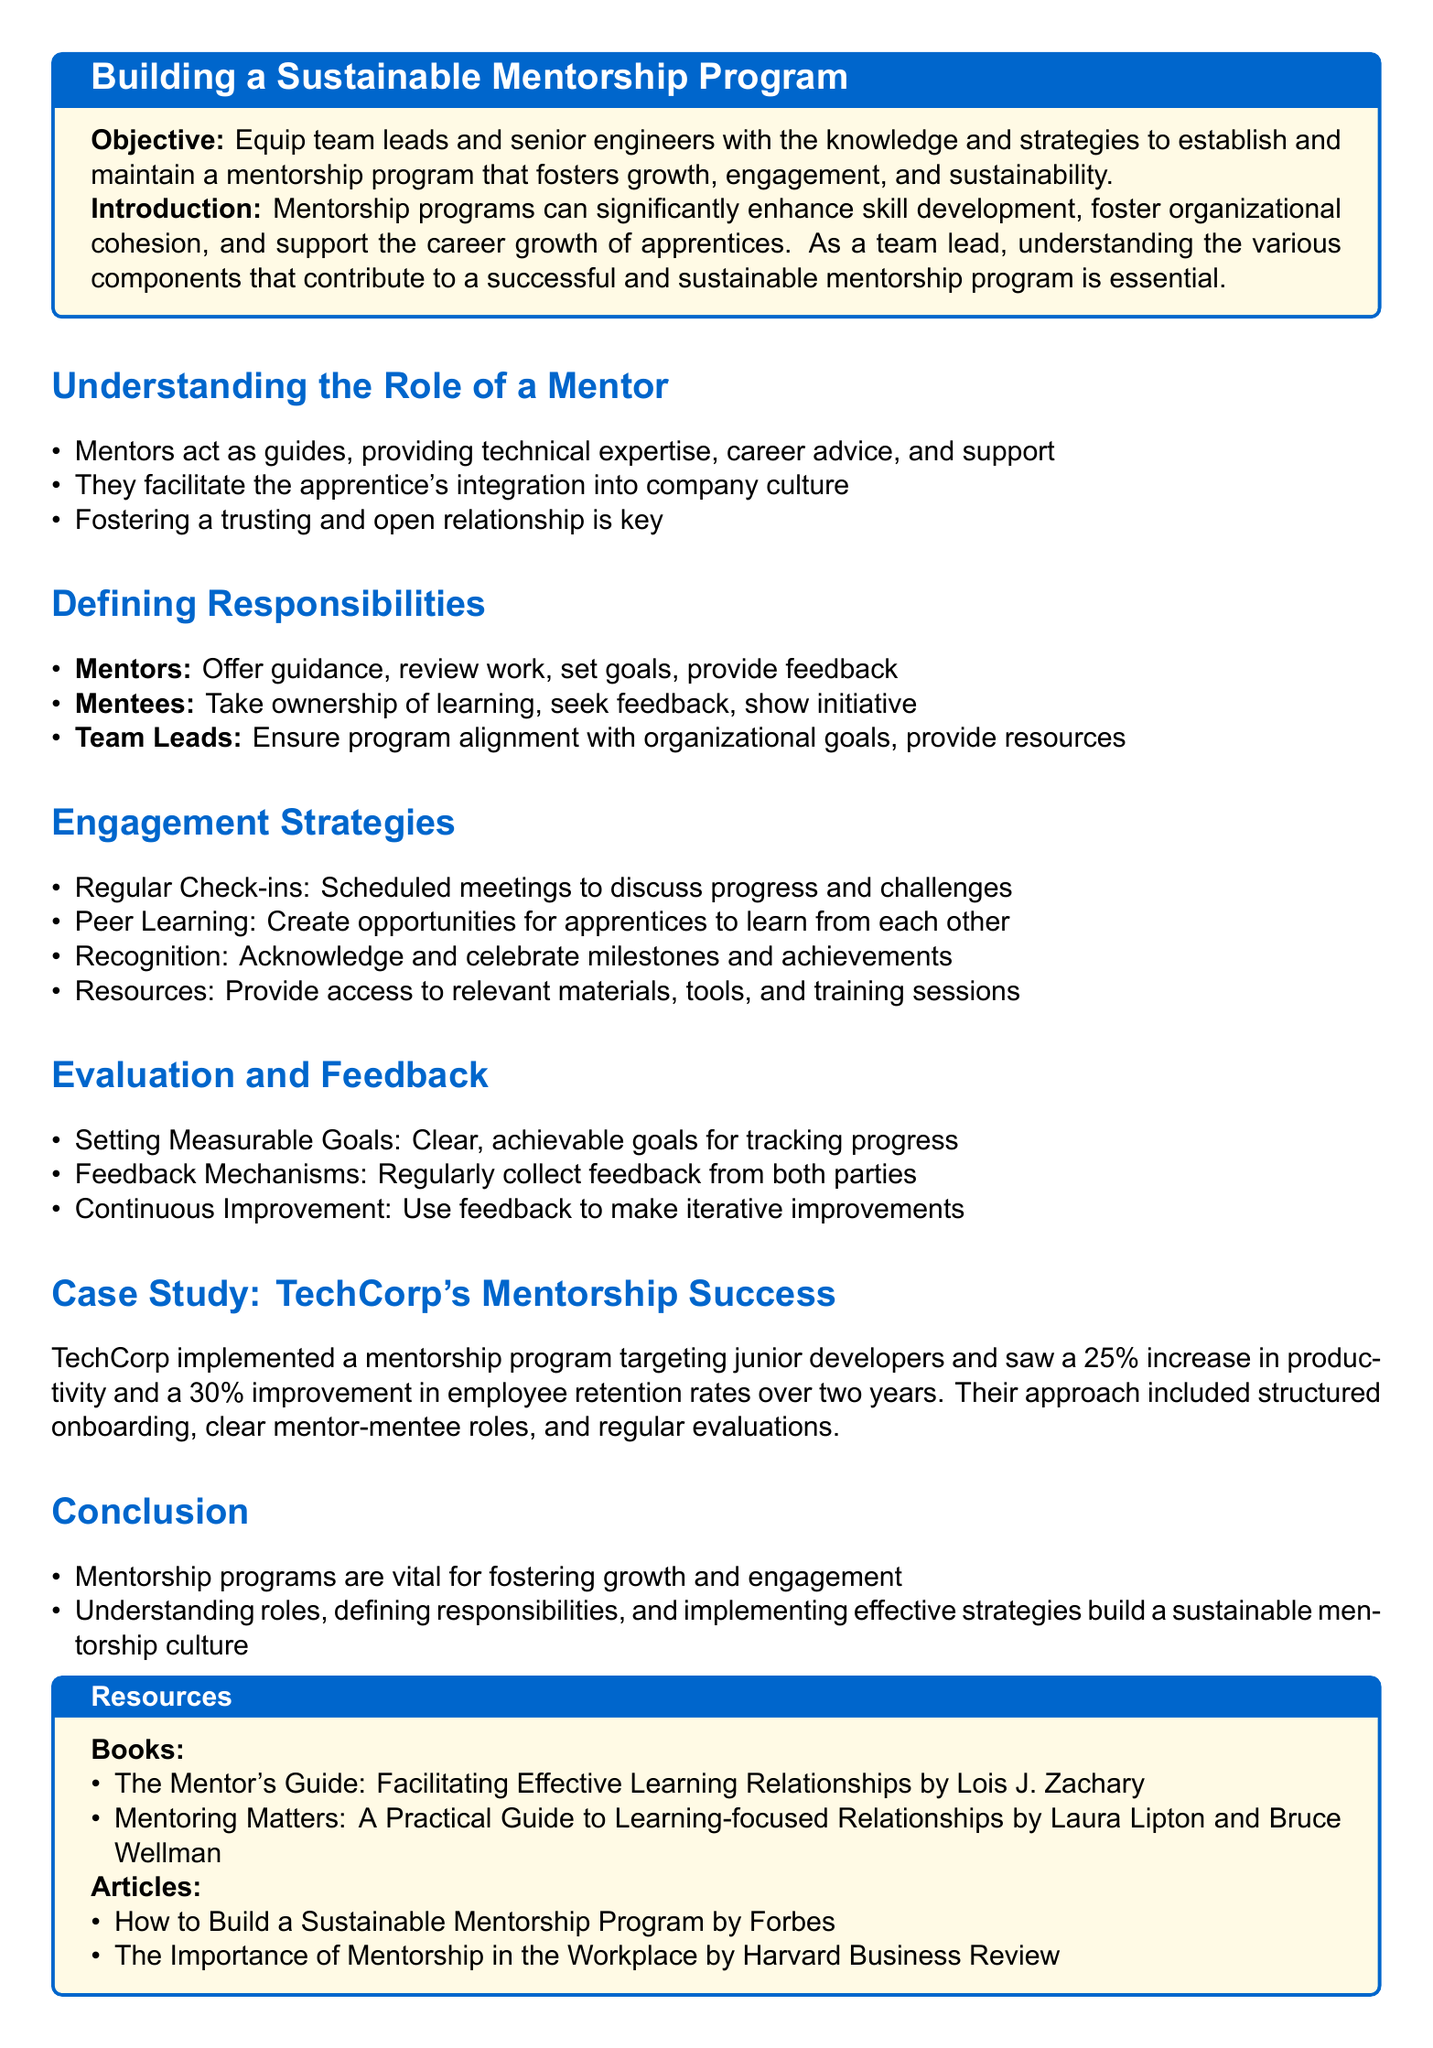What is the objective of the mentorship program? The objective is to equip team leads and senior engineers with the knowledge and strategies to establish and maintain a mentorship program that fosters growth, engagement, and sustainability.
Answer: To equip team leads and senior engineers with the knowledge and strategies to establish and maintain a mentorship program What is one role of a mentor? The document states that mentors act as guides, providing technical expertise, career advice, and support.
Answer: Providing technical expertise Who are the primary participants in the mentorship program? The document defines three main roles in the mentorship program: mentors, mentees, and team leads.
Answer: Mentors, mentees, and team leads What increase in productivity did TechCorp see after implementing their mentorship program? TechCorp experienced a 25% increase in productivity following the program's implementation.
Answer: 25% What engagement strategy involves scheduled meetings? The document lists regular check-ins as a strategy that involves scheduled meetings to discuss progress and challenges.
Answer: Regular check-ins What is a key element for establishing a trusting relationship mentioned in the document? Fostering a trusting and open relationship is emphasized as a key element for effective mentorship.
Answer: Trusting and open relationship What type of feedback mechanism is suggested? The program includes regular collection of feedback from both parties as a feedback mechanism.
Answer: Regular feedback collection What is one resource recommended for mentors? The document lists "The Mentor's Guide: Facilitating Effective Learning Relationships" as a recommended resource.
Answer: The Mentor's Guide How did TechCorp's mentorship program impact employee retention rates? The company saw a 30% improvement in employee retention rates over two years due to the mentorship program.
Answer: 30% 